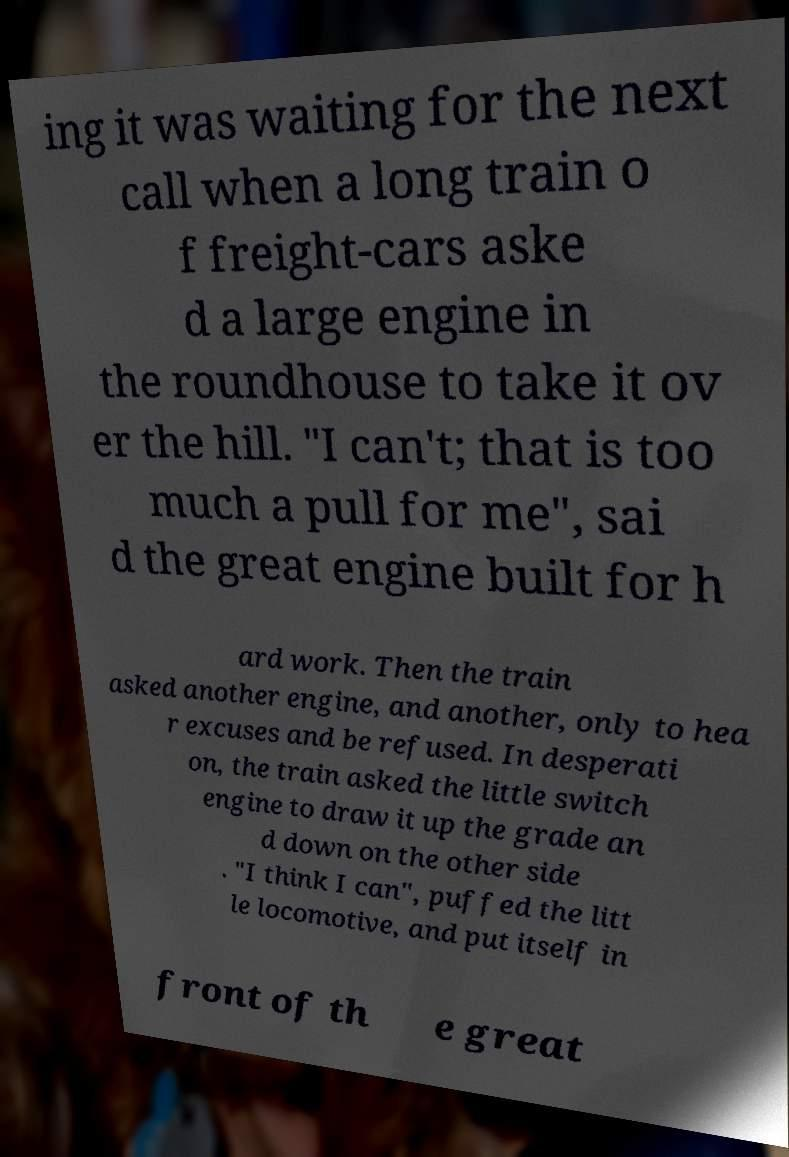Please read and relay the text visible in this image. What does it say? ing it was waiting for the next call when a long train o f freight-cars aske d a large engine in the roundhouse to take it ov er the hill. "I can't; that is too much a pull for me", sai d the great engine built for h ard work. Then the train asked another engine, and another, only to hea r excuses and be refused. In desperati on, the train asked the little switch engine to draw it up the grade an d down on the other side . "I think I can", puffed the litt le locomotive, and put itself in front of th e great 